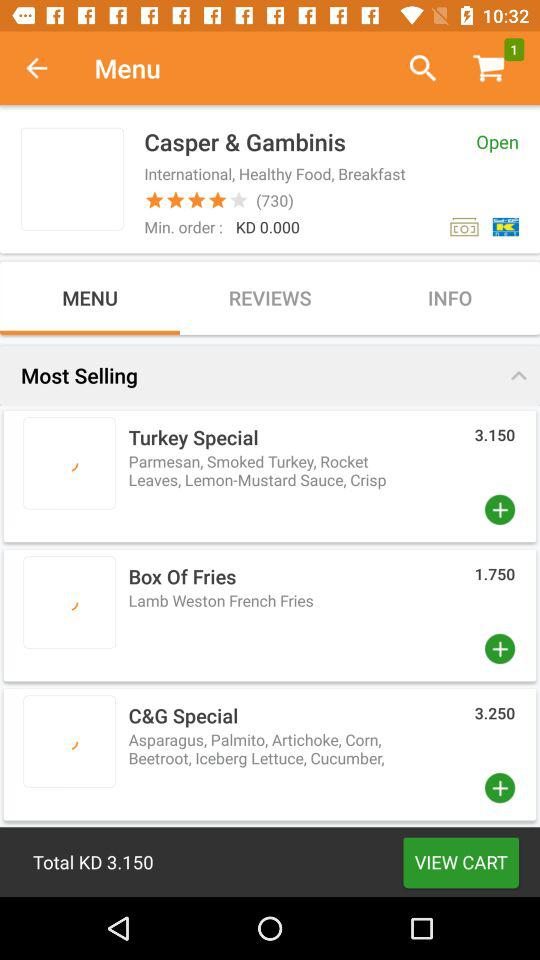How many items are in the shopping cart? There is 1 item in the shopping cart. 